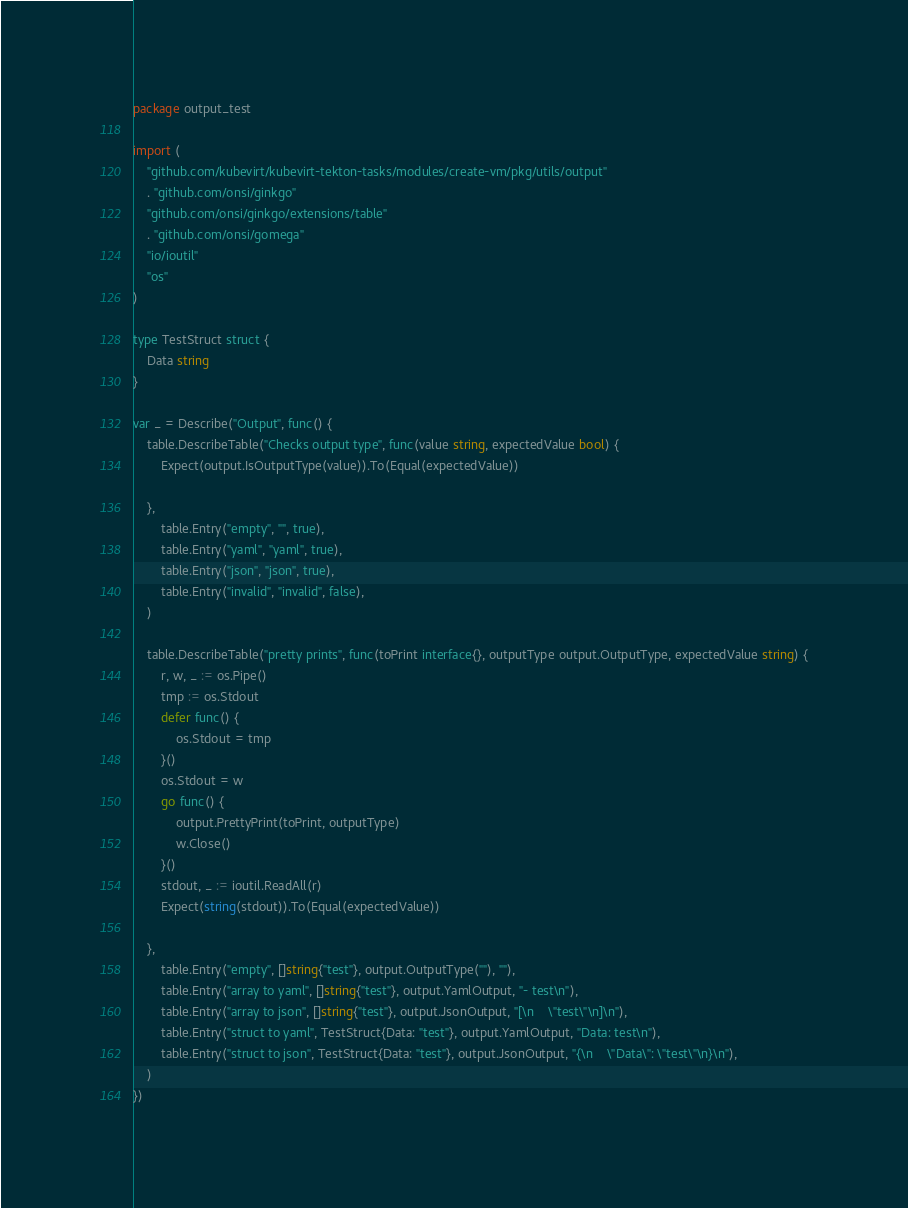Convert code to text. <code><loc_0><loc_0><loc_500><loc_500><_Go_>package output_test

import (
	"github.com/kubevirt/kubevirt-tekton-tasks/modules/create-vm/pkg/utils/output"
	. "github.com/onsi/ginkgo"
	"github.com/onsi/ginkgo/extensions/table"
	. "github.com/onsi/gomega"
	"io/ioutil"
	"os"
)

type TestStruct struct {
	Data string
}

var _ = Describe("Output", func() {
	table.DescribeTable("Checks output type", func(value string, expectedValue bool) {
		Expect(output.IsOutputType(value)).To(Equal(expectedValue))

	},
		table.Entry("empty", "", true),
		table.Entry("yaml", "yaml", true),
		table.Entry("json", "json", true),
		table.Entry("invalid", "invalid", false),
	)

	table.DescribeTable("pretty prints", func(toPrint interface{}, outputType output.OutputType, expectedValue string) {
		r, w, _ := os.Pipe()
		tmp := os.Stdout
		defer func() {
			os.Stdout = tmp
		}()
		os.Stdout = w
		go func() {
			output.PrettyPrint(toPrint, outputType)
			w.Close()
		}()
		stdout, _ := ioutil.ReadAll(r)
		Expect(string(stdout)).To(Equal(expectedValue))

	},
		table.Entry("empty", []string{"test"}, output.OutputType(""), ""),
		table.Entry("array to yaml", []string{"test"}, output.YamlOutput, "- test\n"),
		table.Entry("array to json", []string{"test"}, output.JsonOutput, "[\n    \"test\"\n]\n"),
		table.Entry("struct to yaml", TestStruct{Data: "test"}, output.YamlOutput, "Data: test\n"),
		table.Entry("struct to json", TestStruct{Data: "test"}, output.JsonOutput, "{\n    \"Data\": \"test\"\n}\n"),
	)
})
</code> 